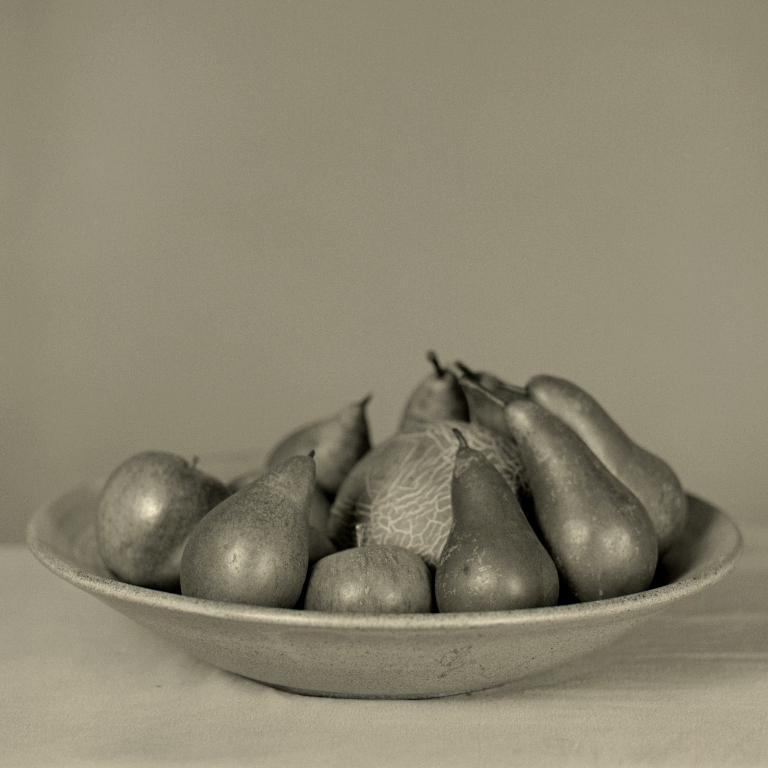What types of food items are visible in the image? There are fruits and vegetables in the image. How are the fruits and vegetables arranged in the image? The fruits and vegetables are on a plate. What is the plate resting on in the image? The plate is on some surface. What is the color scheme of the image? The image is in black and white. Can you hear the whistle coming from the fruits and vegetables in the image? There is no whistle present in the image, as it features fruits and vegetables on a plate. How many toes can be seen on the vegetables in the image? Vegetables do not have toes, and there are no human body parts visible in the image. 